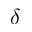Convert formula to latex. <formula><loc_0><loc_0><loc_500><loc_500>\delta</formula> 